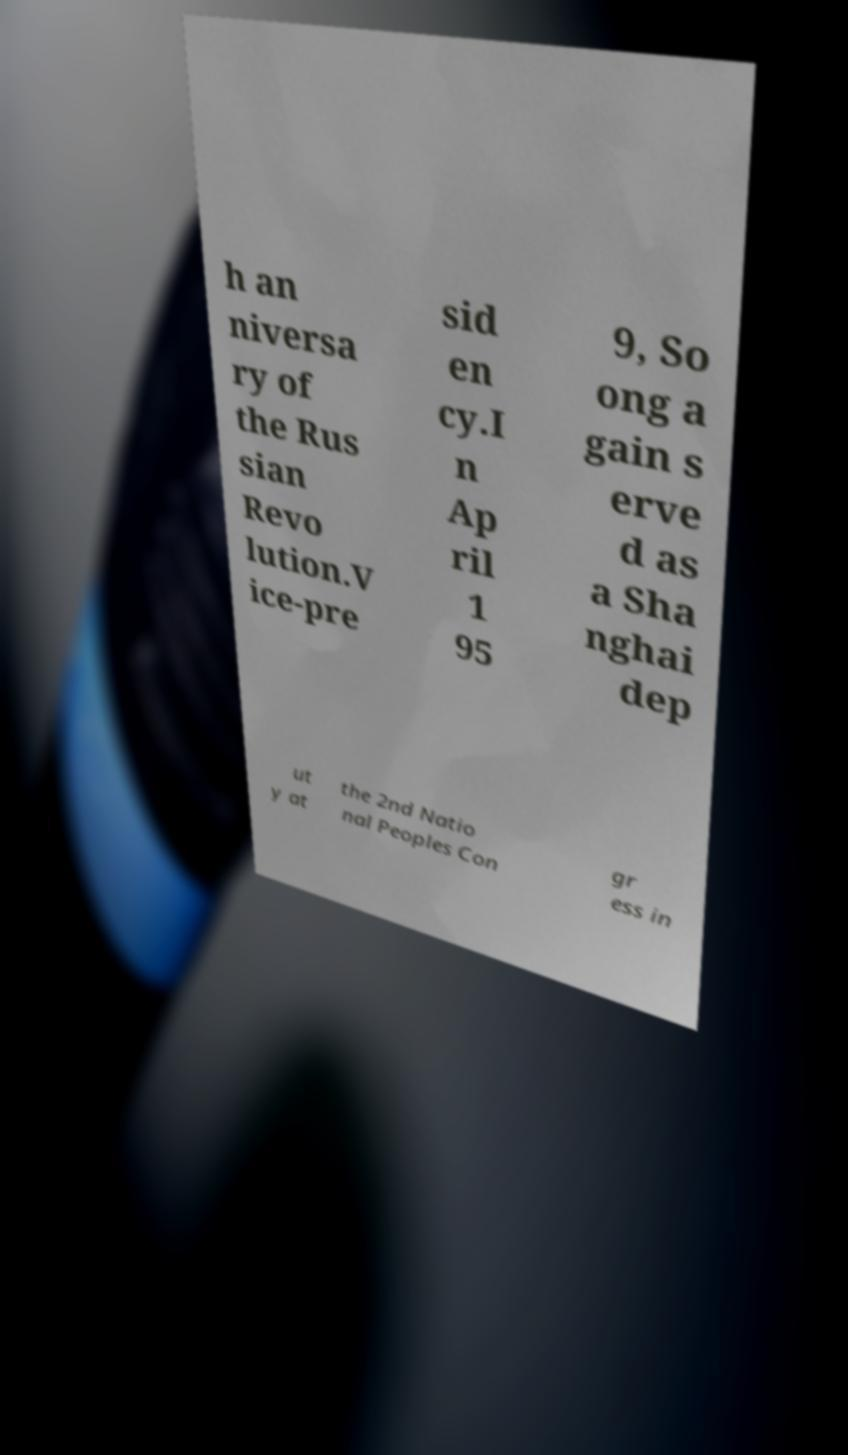Please read and relay the text visible in this image. What does it say? h an niversa ry of the Rus sian Revo lution.V ice-pre sid en cy.I n Ap ril 1 95 9, So ong a gain s erve d as a Sha nghai dep ut y at the 2nd Natio nal Peoples Con gr ess in 